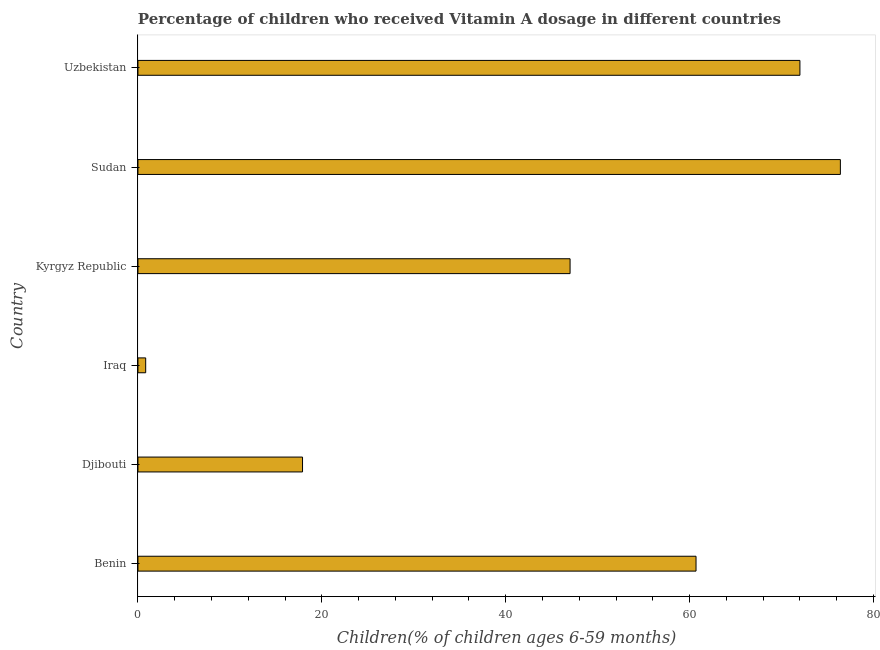What is the title of the graph?
Provide a succinct answer. Percentage of children who received Vitamin A dosage in different countries. What is the label or title of the X-axis?
Offer a very short reply. Children(% of children ages 6-59 months). What is the label or title of the Y-axis?
Offer a very short reply. Country. What is the vitamin a supplementation coverage rate in Benin?
Your answer should be compact. 60.7. Across all countries, what is the maximum vitamin a supplementation coverage rate?
Your answer should be compact. 76.4. Across all countries, what is the minimum vitamin a supplementation coverage rate?
Provide a short and direct response. 0.84. In which country was the vitamin a supplementation coverage rate maximum?
Offer a terse response. Sudan. In which country was the vitamin a supplementation coverage rate minimum?
Give a very brief answer. Iraq. What is the sum of the vitamin a supplementation coverage rate?
Give a very brief answer. 274.84. What is the difference between the vitamin a supplementation coverage rate in Iraq and Kyrgyz Republic?
Offer a terse response. -46.16. What is the average vitamin a supplementation coverage rate per country?
Your response must be concise. 45.81. What is the median vitamin a supplementation coverage rate?
Keep it short and to the point. 53.85. In how many countries, is the vitamin a supplementation coverage rate greater than 16 %?
Make the answer very short. 5. What is the ratio of the vitamin a supplementation coverage rate in Benin to that in Djibouti?
Your answer should be very brief. 3.39. Is the vitamin a supplementation coverage rate in Djibouti less than that in Uzbekistan?
Provide a succinct answer. Yes. Is the sum of the vitamin a supplementation coverage rate in Benin and Djibouti greater than the maximum vitamin a supplementation coverage rate across all countries?
Offer a terse response. Yes. What is the difference between the highest and the lowest vitamin a supplementation coverage rate?
Keep it short and to the point. 75.56. Are all the bars in the graph horizontal?
Provide a succinct answer. Yes. How many countries are there in the graph?
Your response must be concise. 6. What is the difference between two consecutive major ticks on the X-axis?
Your answer should be compact. 20. Are the values on the major ticks of X-axis written in scientific E-notation?
Keep it short and to the point. No. What is the Children(% of children ages 6-59 months) in Benin?
Offer a very short reply. 60.7. What is the Children(% of children ages 6-59 months) of Iraq?
Provide a succinct answer. 0.84. What is the Children(% of children ages 6-59 months) in Kyrgyz Republic?
Offer a very short reply. 47. What is the Children(% of children ages 6-59 months) in Sudan?
Provide a succinct answer. 76.4. What is the difference between the Children(% of children ages 6-59 months) in Benin and Djibouti?
Your answer should be compact. 42.8. What is the difference between the Children(% of children ages 6-59 months) in Benin and Iraq?
Provide a short and direct response. 59.86. What is the difference between the Children(% of children ages 6-59 months) in Benin and Sudan?
Offer a very short reply. -15.7. What is the difference between the Children(% of children ages 6-59 months) in Djibouti and Iraq?
Make the answer very short. 17.06. What is the difference between the Children(% of children ages 6-59 months) in Djibouti and Kyrgyz Republic?
Offer a terse response. -29.1. What is the difference between the Children(% of children ages 6-59 months) in Djibouti and Sudan?
Ensure brevity in your answer.  -58.5. What is the difference between the Children(% of children ages 6-59 months) in Djibouti and Uzbekistan?
Your answer should be compact. -54.1. What is the difference between the Children(% of children ages 6-59 months) in Iraq and Kyrgyz Republic?
Provide a short and direct response. -46.16. What is the difference between the Children(% of children ages 6-59 months) in Iraq and Sudan?
Keep it short and to the point. -75.56. What is the difference between the Children(% of children ages 6-59 months) in Iraq and Uzbekistan?
Your answer should be compact. -71.16. What is the difference between the Children(% of children ages 6-59 months) in Kyrgyz Republic and Sudan?
Your answer should be very brief. -29.4. What is the ratio of the Children(% of children ages 6-59 months) in Benin to that in Djibouti?
Your response must be concise. 3.39. What is the ratio of the Children(% of children ages 6-59 months) in Benin to that in Iraq?
Your answer should be compact. 72.26. What is the ratio of the Children(% of children ages 6-59 months) in Benin to that in Kyrgyz Republic?
Offer a very short reply. 1.29. What is the ratio of the Children(% of children ages 6-59 months) in Benin to that in Sudan?
Provide a short and direct response. 0.8. What is the ratio of the Children(% of children ages 6-59 months) in Benin to that in Uzbekistan?
Offer a terse response. 0.84. What is the ratio of the Children(% of children ages 6-59 months) in Djibouti to that in Iraq?
Your response must be concise. 21.31. What is the ratio of the Children(% of children ages 6-59 months) in Djibouti to that in Kyrgyz Republic?
Give a very brief answer. 0.38. What is the ratio of the Children(% of children ages 6-59 months) in Djibouti to that in Sudan?
Offer a very short reply. 0.23. What is the ratio of the Children(% of children ages 6-59 months) in Djibouti to that in Uzbekistan?
Provide a short and direct response. 0.25. What is the ratio of the Children(% of children ages 6-59 months) in Iraq to that in Kyrgyz Republic?
Give a very brief answer. 0.02. What is the ratio of the Children(% of children ages 6-59 months) in Iraq to that in Sudan?
Offer a very short reply. 0.01. What is the ratio of the Children(% of children ages 6-59 months) in Iraq to that in Uzbekistan?
Your response must be concise. 0.01. What is the ratio of the Children(% of children ages 6-59 months) in Kyrgyz Republic to that in Sudan?
Offer a very short reply. 0.61. What is the ratio of the Children(% of children ages 6-59 months) in Kyrgyz Republic to that in Uzbekistan?
Offer a terse response. 0.65. What is the ratio of the Children(% of children ages 6-59 months) in Sudan to that in Uzbekistan?
Provide a short and direct response. 1.06. 